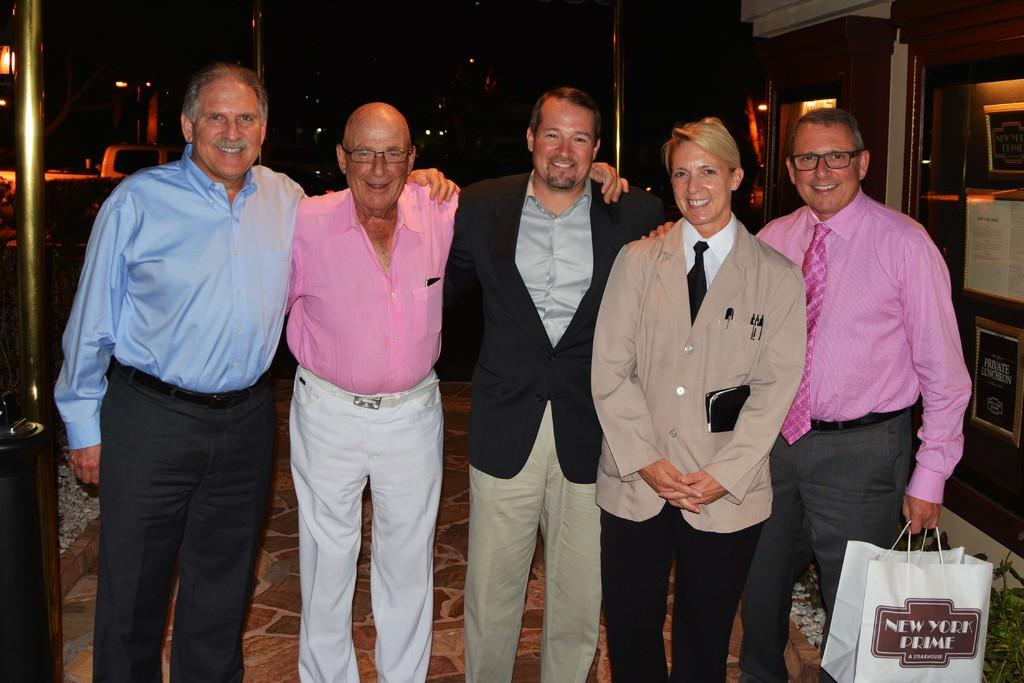How many people are in the image? There are 5 people in the image. What are the people doing in the image? The people are standing and smiling. Can you describe any objects that one of the people is holding? One person is holding a white carry bag. What type of juice can be seen in the image? There is no juice present in the image. How many pages are visible in the image? There are no pages present in the image. 